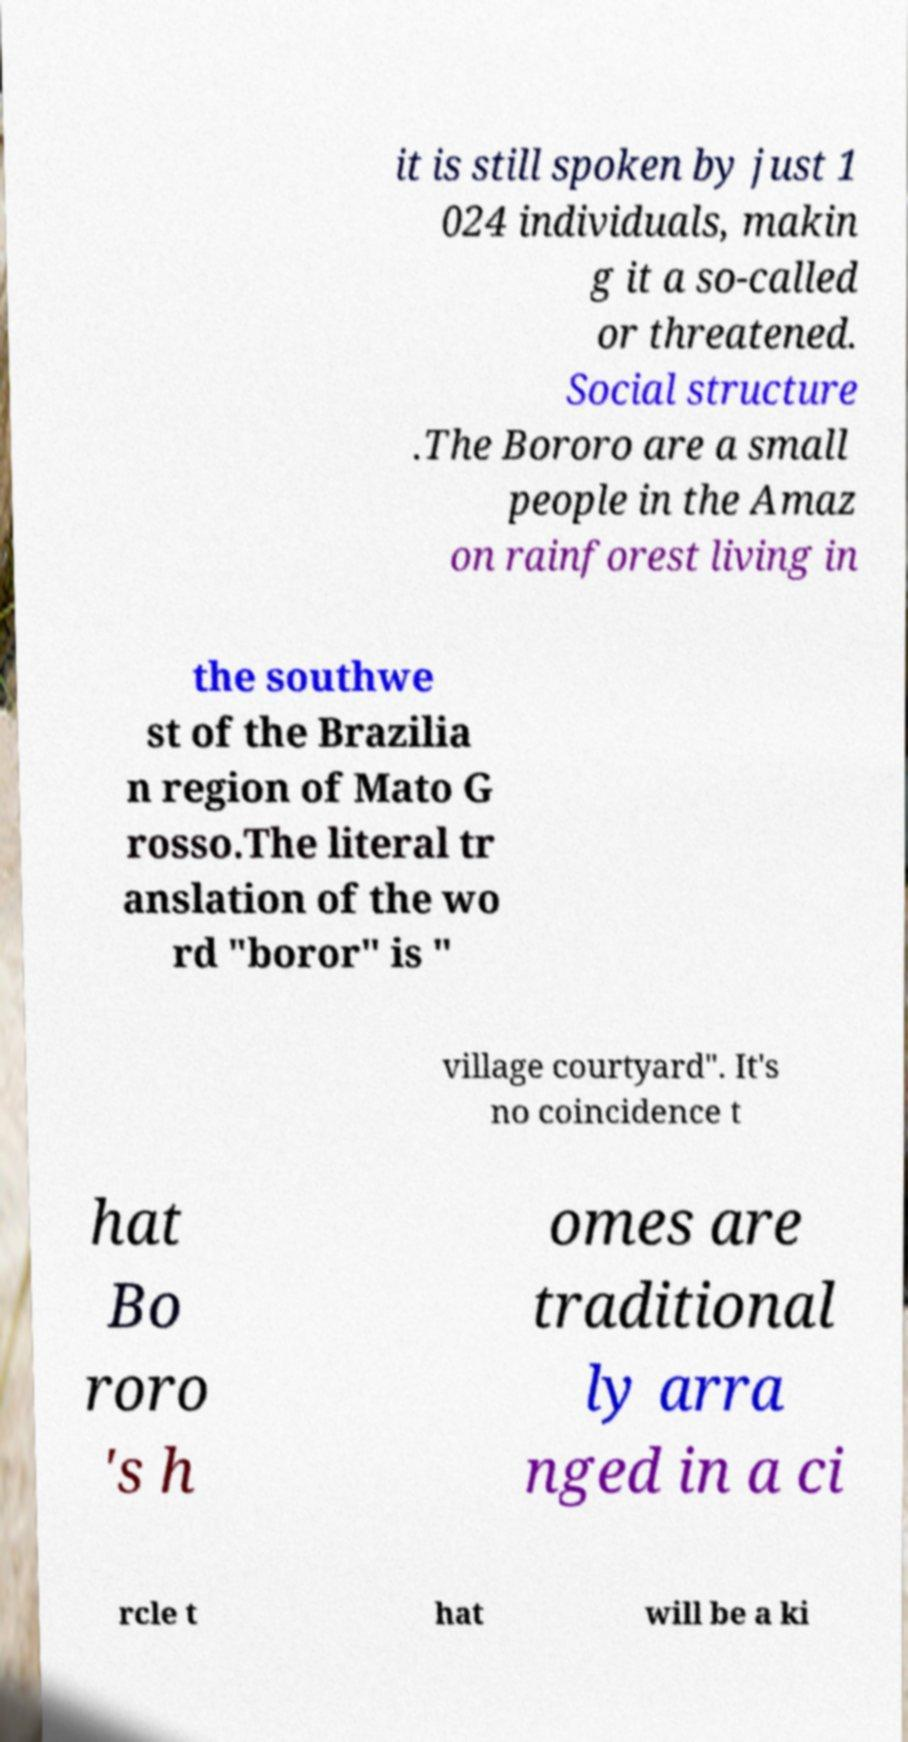Could you extract and type out the text from this image? it is still spoken by just 1 024 individuals, makin g it a so-called or threatened. Social structure .The Bororo are a small people in the Amaz on rainforest living in the southwe st of the Brazilia n region of Mato G rosso.The literal tr anslation of the wo rd "boror" is " village courtyard". It's no coincidence t hat Bo roro 's h omes are traditional ly arra nged in a ci rcle t hat will be a ki 